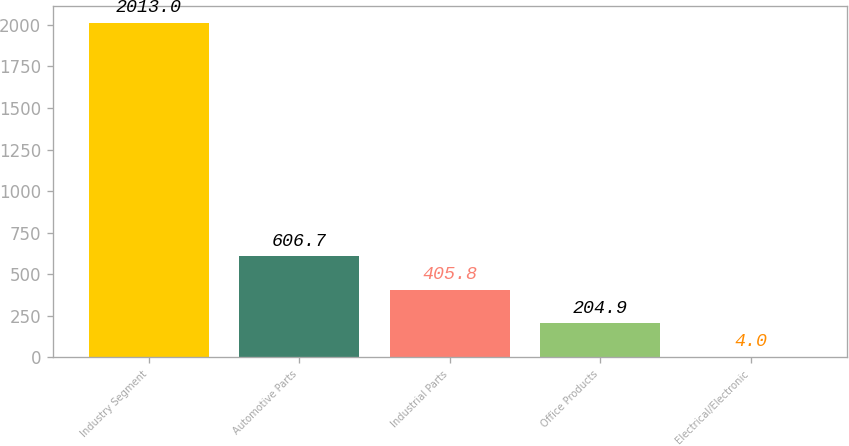<chart> <loc_0><loc_0><loc_500><loc_500><bar_chart><fcel>Industry Segment<fcel>Automotive Parts<fcel>Industrial Parts<fcel>Office Products<fcel>Electrical/Electronic<nl><fcel>2013<fcel>606.7<fcel>405.8<fcel>204.9<fcel>4<nl></chart> 